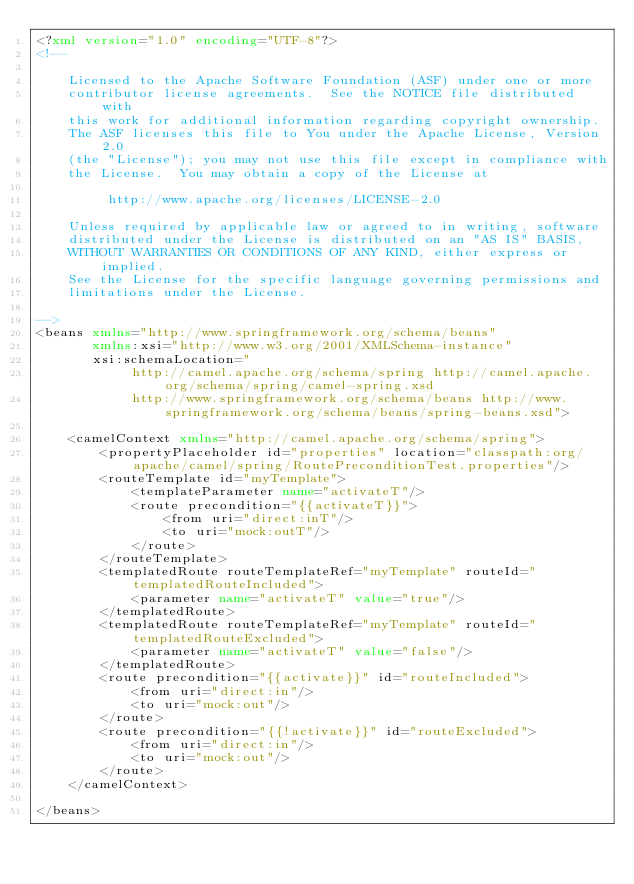<code> <loc_0><loc_0><loc_500><loc_500><_XML_><?xml version="1.0" encoding="UTF-8"?>
<!--

    Licensed to the Apache Software Foundation (ASF) under one or more
    contributor license agreements.  See the NOTICE file distributed with
    this work for additional information regarding copyright ownership.
    The ASF licenses this file to You under the Apache License, Version 2.0
    (the "License"); you may not use this file except in compliance with
    the License.  You may obtain a copy of the License at

         http://www.apache.org/licenses/LICENSE-2.0

    Unless required by applicable law or agreed to in writing, software
    distributed under the License is distributed on an "AS IS" BASIS,
    WITHOUT WARRANTIES OR CONDITIONS OF ANY KIND, either express or implied.
    See the License for the specific language governing permissions and
    limitations under the License.

-->
<beans xmlns="http://www.springframework.org/schema/beans"
       xmlns:xsi="http://www.w3.org/2001/XMLSchema-instance"
       xsi:schemaLocation="
            http://camel.apache.org/schema/spring http://camel.apache.org/schema/spring/camel-spring.xsd
            http://www.springframework.org/schema/beans http://www.springframework.org/schema/beans/spring-beans.xsd">

    <camelContext xmlns="http://camel.apache.org/schema/spring">
        <propertyPlaceholder id="properties" location="classpath:org/apache/camel/spring/RoutePreconditionTest.properties"/>
        <routeTemplate id="myTemplate">
            <templateParameter name="activateT"/>
            <route precondition="{{activateT}}">
                <from uri="direct:inT"/>
                <to uri="mock:outT"/>
            </route>
        </routeTemplate>
        <templatedRoute routeTemplateRef="myTemplate" routeId="templatedRouteIncluded">
            <parameter name="activateT" value="true"/>
        </templatedRoute>
        <templatedRoute routeTemplateRef="myTemplate" routeId="templatedRouteExcluded">
            <parameter name="activateT" value="false"/>
        </templatedRoute>
        <route precondition="{{activate}}" id="routeIncluded">
            <from uri="direct:in"/>
            <to uri="mock:out"/>
        </route>
        <route precondition="{{!activate}}" id="routeExcluded">
            <from uri="direct:in"/>
            <to uri="mock:out"/>
        </route>
    </camelContext>

</beans>
</code> 